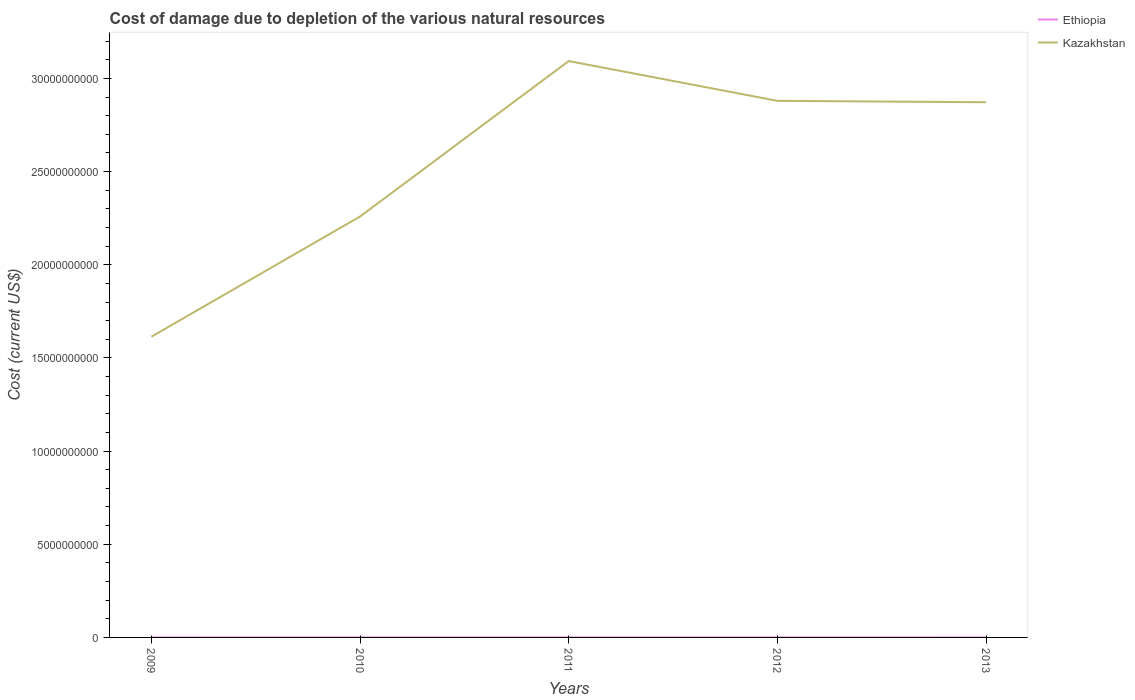Does the line corresponding to Ethiopia intersect with the line corresponding to Kazakhstan?
Offer a very short reply. No. Is the number of lines equal to the number of legend labels?
Give a very brief answer. Yes. Across all years, what is the maximum cost of damage caused due to the depletion of various natural resources in Kazakhstan?
Provide a succinct answer. 1.61e+1. In which year was the cost of damage caused due to the depletion of various natural resources in Kazakhstan maximum?
Your answer should be very brief. 2009. What is the total cost of damage caused due to the depletion of various natural resources in Ethiopia in the graph?
Your answer should be very brief. 7.53e+04. What is the difference between the highest and the second highest cost of damage caused due to the depletion of various natural resources in Kazakhstan?
Make the answer very short. 1.48e+1. How many years are there in the graph?
Offer a very short reply. 5. What is the difference between two consecutive major ticks on the Y-axis?
Offer a very short reply. 5.00e+09. Are the values on the major ticks of Y-axis written in scientific E-notation?
Offer a terse response. No. Does the graph contain any zero values?
Offer a terse response. No. Does the graph contain grids?
Your answer should be very brief. No. How many legend labels are there?
Ensure brevity in your answer.  2. How are the legend labels stacked?
Give a very brief answer. Vertical. What is the title of the graph?
Your response must be concise. Cost of damage due to depletion of the various natural resources. What is the label or title of the Y-axis?
Ensure brevity in your answer.  Cost (current US$). What is the Cost (current US$) in Ethiopia in 2009?
Offer a very short reply. 2.68e+05. What is the Cost (current US$) of Kazakhstan in 2009?
Keep it short and to the point. 1.61e+1. What is the Cost (current US$) of Ethiopia in 2010?
Provide a short and direct response. 1.04e+06. What is the Cost (current US$) in Kazakhstan in 2010?
Provide a short and direct response. 2.26e+1. What is the Cost (current US$) in Ethiopia in 2011?
Your response must be concise. 9.09e+05. What is the Cost (current US$) of Kazakhstan in 2011?
Provide a succinct answer. 3.09e+1. What is the Cost (current US$) of Ethiopia in 2012?
Provide a succinct answer. 6.99e+05. What is the Cost (current US$) in Kazakhstan in 2012?
Keep it short and to the point. 2.88e+1. What is the Cost (current US$) in Ethiopia in 2013?
Ensure brevity in your answer.  6.23e+05. What is the Cost (current US$) in Kazakhstan in 2013?
Make the answer very short. 2.87e+1. Across all years, what is the maximum Cost (current US$) of Ethiopia?
Ensure brevity in your answer.  1.04e+06. Across all years, what is the maximum Cost (current US$) in Kazakhstan?
Your response must be concise. 3.09e+1. Across all years, what is the minimum Cost (current US$) in Ethiopia?
Keep it short and to the point. 2.68e+05. Across all years, what is the minimum Cost (current US$) of Kazakhstan?
Give a very brief answer. 1.61e+1. What is the total Cost (current US$) of Ethiopia in the graph?
Your answer should be very brief. 3.54e+06. What is the total Cost (current US$) of Kazakhstan in the graph?
Offer a terse response. 1.27e+11. What is the difference between the Cost (current US$) in Ethiopia in 2009 and that in 2010?
Offer a terse response. -7.77e+05. What is the difference between the Cost (current US$) in Kazakhstan in 2009 and that in 2010?
Give a very brief answer. -6.45e+09. What is the difference between the Cost (current US$) of Ethiopia in 2009 and that in 2011?
Keep it short and to the point. -6.41e+05. What is the difference between the Cost (current US$) in Kazakhstan in 2009 and that in 2011?
Provide a short and direct response. -1.48e+1. What is the difference between the Cost (current US$) in Ethiopia in 2009 and that in 2012?
Provide a succinct answer. -4.31e+05. What is the difference between the Cost (current US$) in Kazakhstan in 2009 and that in 2012?
Offer a terse response. -1.27e+1. What is the difference between the Cost (current US$) in Ethiopia in 2009 and that in 2013?
Make the answer very short. -3.56e+05. What is the difference between the Cost (current US$) in Kazakhstan in 2009 and that in 2013?
Keep it short and to the point. -1.26e+1. What is the difference between the Cost (current US$) in Ethiopia in 2010 and that in 2011?
Keep it short and to the point. 1.36e+05. What is the difference between the Cost (current US$) of Kazakhstan in 2010 and that in 2011?
Provide a short and direct response. -8.34e+09. What is the difference between the Cost (current US$) of Ethiopia in 2010 and that in 2012?
Offer a terse response. 3.46e+05. What is the difference between the Cost (current US$) in Kazakhstan in 2010 and that in 2012?
Your response must be concise. -6.21e+09. What is the difference between the Cost (current US$) in Ethiopia in 2010 and that in 2013?
Your answer should be compact. 4.21e+05. What is the difference between the Cost (current US$) in Kazakhstan in 2010 and that in 2013?
Keep it short and to the point. -6.13e+09. What is the difference between the Cost (current US$) in Ethiopia in 2011 and that in 2012?
Keep it short and to the point. 2.10e+05. What is the difference between the Cost (current US$) of Kazakhstan in 2011 and that in 2012?
Provide a short and direct response. 2.13e+09. What is the difference between the Cost (current US$) in Ethiopia in 2011 and that in 2013?
Provide a short and direct response. 2.85e+05. What is the difference between the Cost (current US$) of Kazakhstan in 2011 and that in 2013?
Your response must be concise. 2.21e+09. What is the difference between the Cost (current US$) in Ethiopia in 2012 and that in 2013?
Your response must be concise. 7.53e+04. What is the difference between the Cost (current US$) of Kazakhstan in 2012 and that in 2013?
Give a very brief answer. 7.44e+07. What is the difference between the Cost (current US$) of Ethiopia in 2009 and the Cost (current US$) of Kazakhstan in 2010?
Your answer should be very brief. -2.26e+1. What is the difference between the Cost (current US$) in Ethiopia in 2009 and the Cost (current US$) in Kazakhstan in 2011?
Provide a succinct answer. -3.09e+1. What is the difference between the Cost (current US$) in Ethiopia in 2009 and the Cost (current US$) in Kazakhstan in 2012?
Provide a succinct answer. -2.88e+1. What is the difference between the Cost (current US$) of Ethiopia in 2009 and the Cost (current US$) of Kazakhstan in 2013?
Keep it short and to the point. -2.87e+1. What is the difference between the Cost (current US$) of Ethiopia in 2010 and the Cost (current US$) of Kazakhstan in 2011?
Give a very brief answer. -3.09e+1. What is the difference between the Cost (current US$) of Ethiopia in 2010 and the Cost (current US$) of Kazakhstan in 2012?
Ensure brevity in your answer.  -2.88e+1. What is the difference between the Cost (current US$) in Ethiopia in 2010 and the Cost (current US$) in Kazakhstan in 2013?
Ensure brevity in your answer.  -2.87e+1. What is the difference between the Cost (current US$) of Ethiopia in 2011 and the Cost (current US$) of Kazakhstan in 2012?
Ensure brevity in your answer.  -2.88e+1. What is the difference between the Cost (current US$) of Ethiopia in 2011 and the Cost (current US$) of Kazakhstan in 2013?
Your answer should be very brief. -2.87e+1. What is the difference between the Cost (current US$) of Ethiopia in 2012 and the Cost (current US$) of Kazakhstan in 2013?
Offer a terse response. -2.87e+1. What is the average Cost (current US$) in Ethiopia per year?
Provide a short and direct response. 7.09e+05. What is the average Cost (current US$) of Kazakhstan per year?
Your answer should be compact. 2.54e+1. In the year 2009, what is the difference between the Cost (current US$) in Ethiopia and Cost (current US$) in Kazakhstan?
Provide a short and direct response. -1.61e+1. In the year 2010, what is the difference between the Cost (current US$) of Ethiopia and Cost (current US$) of Kazakhstan?
Keep it short and to the point. -2.26e+1. In the year 2011, what is the difference between the Cost (current US$) in Ethiopia and Cost (current US$) in Kazakhstan?
Offer a very short reply. -3.09e+1. In the year 2012, what is the difference between the Cost (current US$) in Ethiopia and Cost (current US$) in Kazakhstan?
Provide a succinct answer. -2.88e+1. In the year 2013, what is the difference between the Cost (current US$) in Ethiopia and Cost (current US$) in Kazakhstan?
Offer a very short reply. -2.87e+1. What is the ratio of the Cost (current US$) in Ethiopia in 2009 to that in 2010?
Your answer should be very brief. 0.26. What is the ratio of the Cost (current US$) of Kazakhstan in 2009 to that in 2010?
Your answer should be very brief. 0.71. What is the ratio of the Cost (current US$) of Ethiopia in 2009 to that in 2011?
Keep it short and to the point. 0.29. What is the ratio of the Cost (current US$) in Kazakhstan in 2009 to that in 2011?
Make the answer very short. 0.52. What is the ratio of the Cost (current US$) in Ethiopia in 2009 to that in 2012?
Your answer should be very brief. 0.38. What is the ratio of the Cost (current US$) of Kazakhstan in 2009 to that in 2012?
Provide a succinct answer. 0.56. What is the ratio of the Cost (current US$) of Ethiopia in 2009 to that in 2013?
Your answer should be very brief. 0.43. What is the ratio of the Cost (current US$) of Kazakhstan in 2009 to that in 2013?
Your answer should be compact. 0.56. What is the ratio of the Cost (current US$) in Ethiopia in 2010 to that in 2011?
Your answer should be compact. 1.15. What is the ratio of the Cost (current US$) in Kazakhstan in 2010 to that in 2011?
Provide a succinct answer. 0.73. What is the ratio of the Cost (current US$) of Ethiopia in 2010 to that in 2012?
Offer a terse response. 1.5. What is the ratio of the Cost (current US$) of Kazakhstan in 2010 to that in 2012?
Offer a very short reply. 0.78. What is the ratio of the Cost (current US$) in Ethiopia in 2010 to that in 2013?
Offer a terse response. 1.68. What is the ratio of the Cost (current US$) of Kazakhstan in 2010 to that in 2013?
Offer a very short reply. 0.79. What is the ratio of the Cost (current US$) in Ethiopia in 2011 to that in 2012?
Keep it short and to the point. 1.3. What is the ratio of the Cost (current US$) of Kazakhstan in 2011 to that in 2012?
Give a very brief answer. 1.07. What is the ratio of the Cost (current US$) in Ethiopia in 2011 to that in 2013?
Ensure brevity in your answer.  1.46. What is the ratio of the Cost (current US$) in Ethiopia in 2012 to that in 2013?
Your answer should be very brief. 1.12. What is the difference between the highest and the second highest Cost (current US$) in Ethiopia?
Your response must be concise. 1.36e+05. What is the difference between the highest and the second highest Cost (current US$) in Kazakhstan?
Your answer should be compact. 2.13e+09. What is the difference between the highest and the lowest Cost (current US$) in Ethiopia?
Make the answer very short. 7.77e+05. What is the difference between the highest and the lowest Cost (current US$) in Kazakhstan?
Your answer should be very brief. 1.48e+1. 